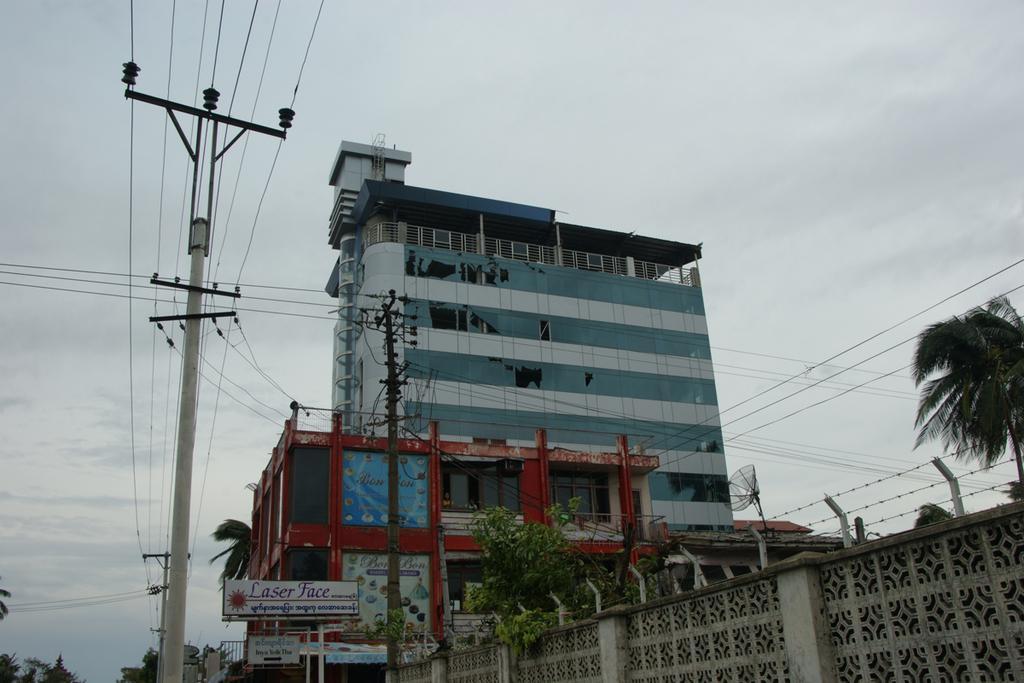Can you describe this image briefly? In this image we can see buildings, trees, banners, poles and electric wires. Background of the image sky is there with clouds. 